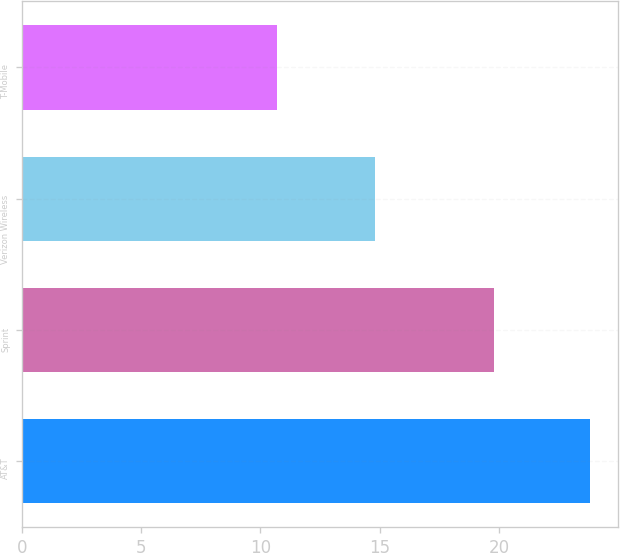Convert chart. <chart><loc_0><loc_0><loc_500><loc_500><bar_chart><fcel>AT&T<fcel>Sprint<fcel>Verizon Wireless<fcel>T-Mobile<nl><fcel>23.8<fcel>19.8<fcel>14.8<fcel>10.7<nl></chart> 